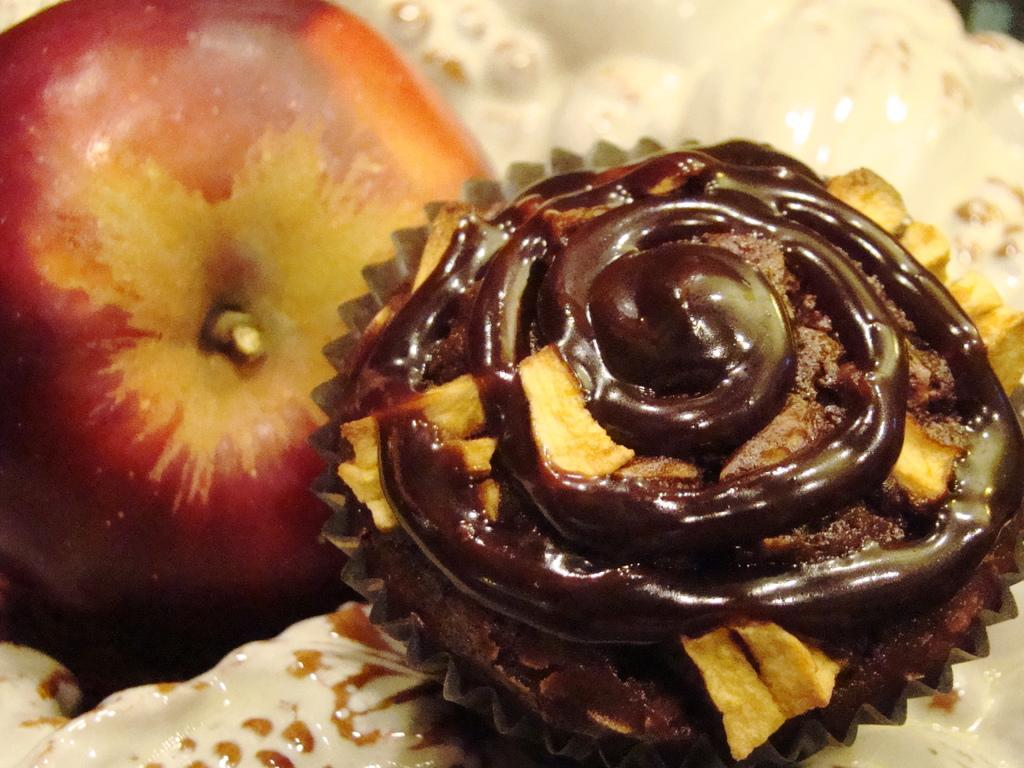What type of fruit is in the image? There is an apple in the image. What type of baked good is in the image? There is a muffin in the image. How is the muffin presented in the image? The muffin is in the cream. What type of tax is being discussed in the image? There is no discussion of tax in the image; it features an apple and a muffin in cream. What type of approval is being sought in the image? There is no approval being sought in the image; it features an apple and a muffin in cream. 